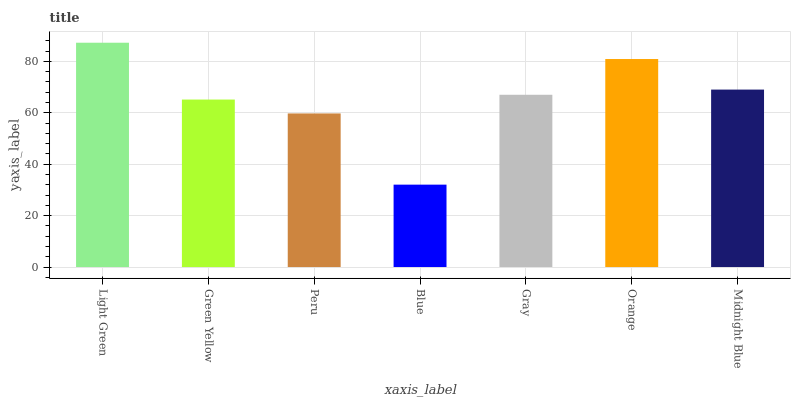Is Blue the minimum?
Answer yes or no. Yes. Is Light Green the maximum?
Answer yes or no. Yes. Is Green Yellow the minimum?
Answer yes or no. No. Is Green Yellow the maximum?
Answer yes or no. No. Is Light Green greater than Green Yellow?
Answer yes or no. Yes. Is Green Yellow less than Light Green?
Answer yes or no. Yes. Is Green Yellow greater than Light Green?
Answer yes or no. No. Is Light Green less than Green Yellow?
Answer yes or no. No. Is Gray the high median?
Answer yes or no. Yes. Is Gray the low median?
Answer yes or no. Yes. Is Green Yellow the high median?
Answer yes or no. No. Is Orange the low median?
Answer yes or no. No. 